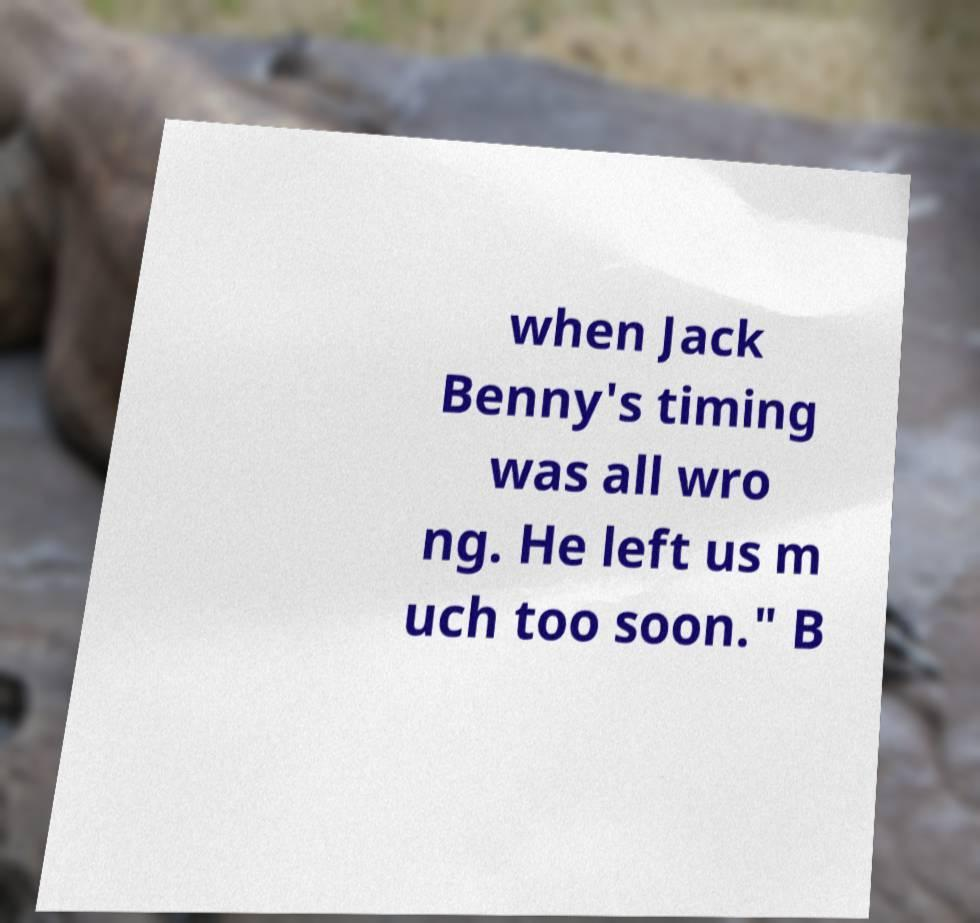I need the written content from this picture converted into text. Can you do that? when Jack Benny's timing was all wro ng. He left us m uch too soon." B 